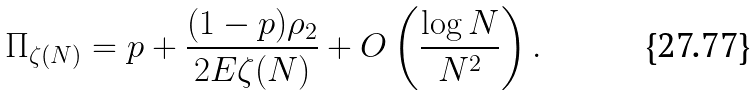<formula> <loc_0><loc_0><loc_500><loc_500>\Pi _ { \zeta ( N ) } = p + \frac { ( 1 - p ) \rho _ { 2 } } { 2 E \zeta ( N ) } + O \left ( \frac { \log N } { N ^ { 2 } } \right ) .</formula> 